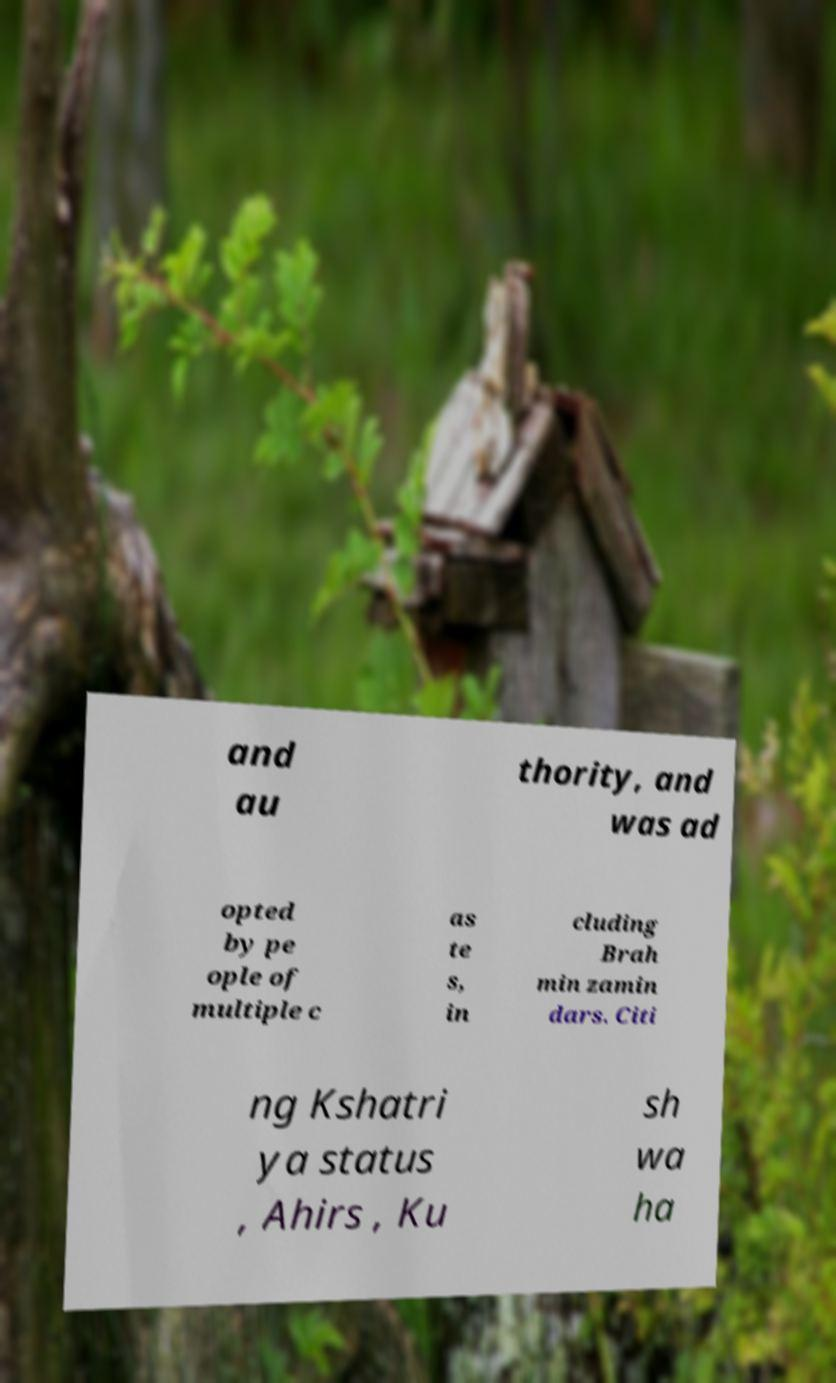Please read and relay the text visible in this image. What does it say? and au thority, and was ad opted by pe ople of multiple c as te s, in cluding Brah min zamin dars. Citi ng Kshatri ya status , Ahirs , Ku sh wa ha 